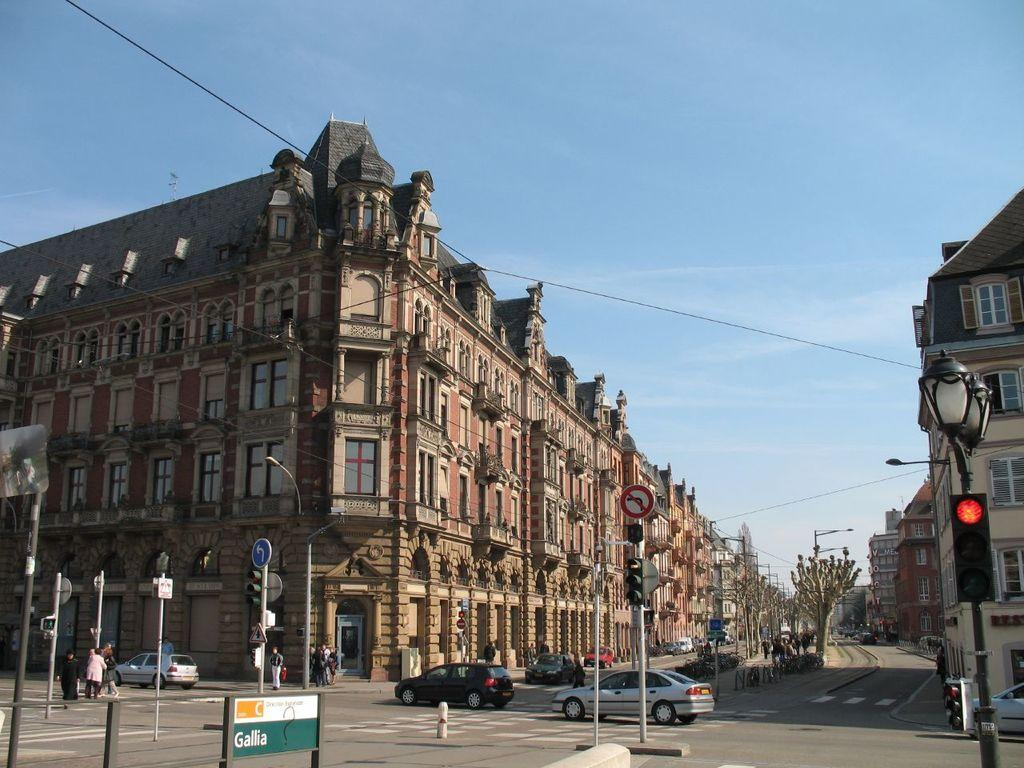Who or what can be seen in the image? There are people in the image. What else is present in the scene? There are cars and electrical poles in the image. Where does the scene take place? The scene takes place on a road. What can be seen in the background of the image? There are buildings beside the road. What type of paste is being used to cover the electrical poles in the image? There is no paste or any indication of covering the electrical poles in the image. 